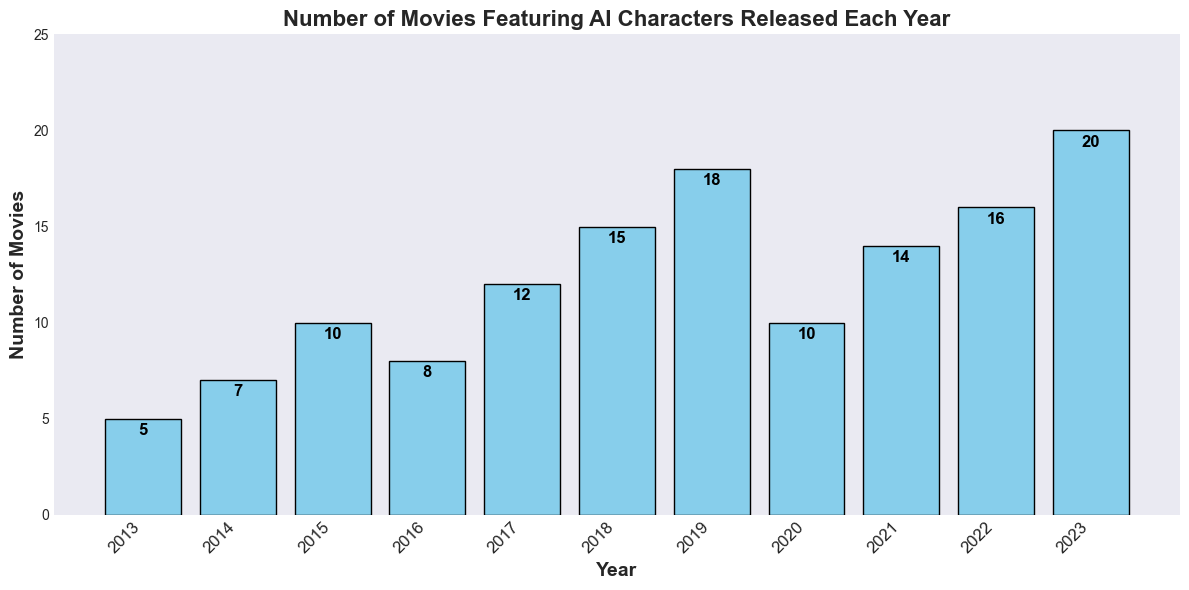What was the year with the highest number of movies featuring AI characters? To answer this, scan the bars to find the tallest one. The year label below this bar indicates the year with the highest number of movies. In this case, the tallest bar corresponds to the year 2023.
Answer: 2023 In which year were the number of AI movies exactly double that of 2013? In 2013, 5 movies were released. Scan the bars to find a year with a movie count of 10. The year 2015 shows a bar with 10 movies, which is double the number in 2013.
Answer: 2015 By how many did the number of AI movies increase from 2017 to 2018? The bar for 2017 shows 12 movies, and the bar for 2018 shows 15 movies. Subtract 12 from 15 to find the increase.
Answer: 3 What is the average number of AI movies released per year over the last three years (2021-2023)? Sum the number of movies for the years 2021 (14), 2022 (16), and 2023 (20), which gives 14 + 16 + 20 = 50. Divide this by 3 to get the average: 50/3 ≈ 16.67.
Answer: 16.67 What is the total number of AI movies released between 2016 and 2018 inclusive? Add the number of movies for the years 2016 (8), 2017 (12), and 2018 (15). The total is 8 + 12 + 15 = 35.
Answer: 35 Which year saw a decrease in the number of AI movies compared to the previous year? Observe the height of the bars year by year. From 2019 to 2020, the number dropped from 18 to 10, indicating a decrease.
Answer: 2020 How many more AI movies were released in 2023 compared to 2020? The bar for 2023 shows 20 movies, and the bar for 2020 shows 10 movies. Subtract 10 from 20 to find the difference.
Answer: 10 Which two consecutive years saw the greatest increase in the number of AI movies? Compare the difference in the height of bars for each consecutive year. The largest increase is between 2018 (15) and 2019 (18), which is an increase of 3 movies.
Answer: 2018-2019 